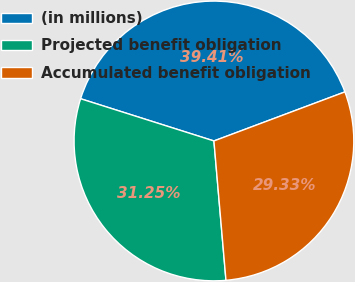<chart> <loc_0><loc_0><loc_500><loc_500><pie_chart><fcel>(in millions)<fcel>Projected benefit obligation<fcel>Accumulated benefit obligation<nl><fcel>39.41%<fcel>31.25%<fcel>29.33%<nl></chart> 